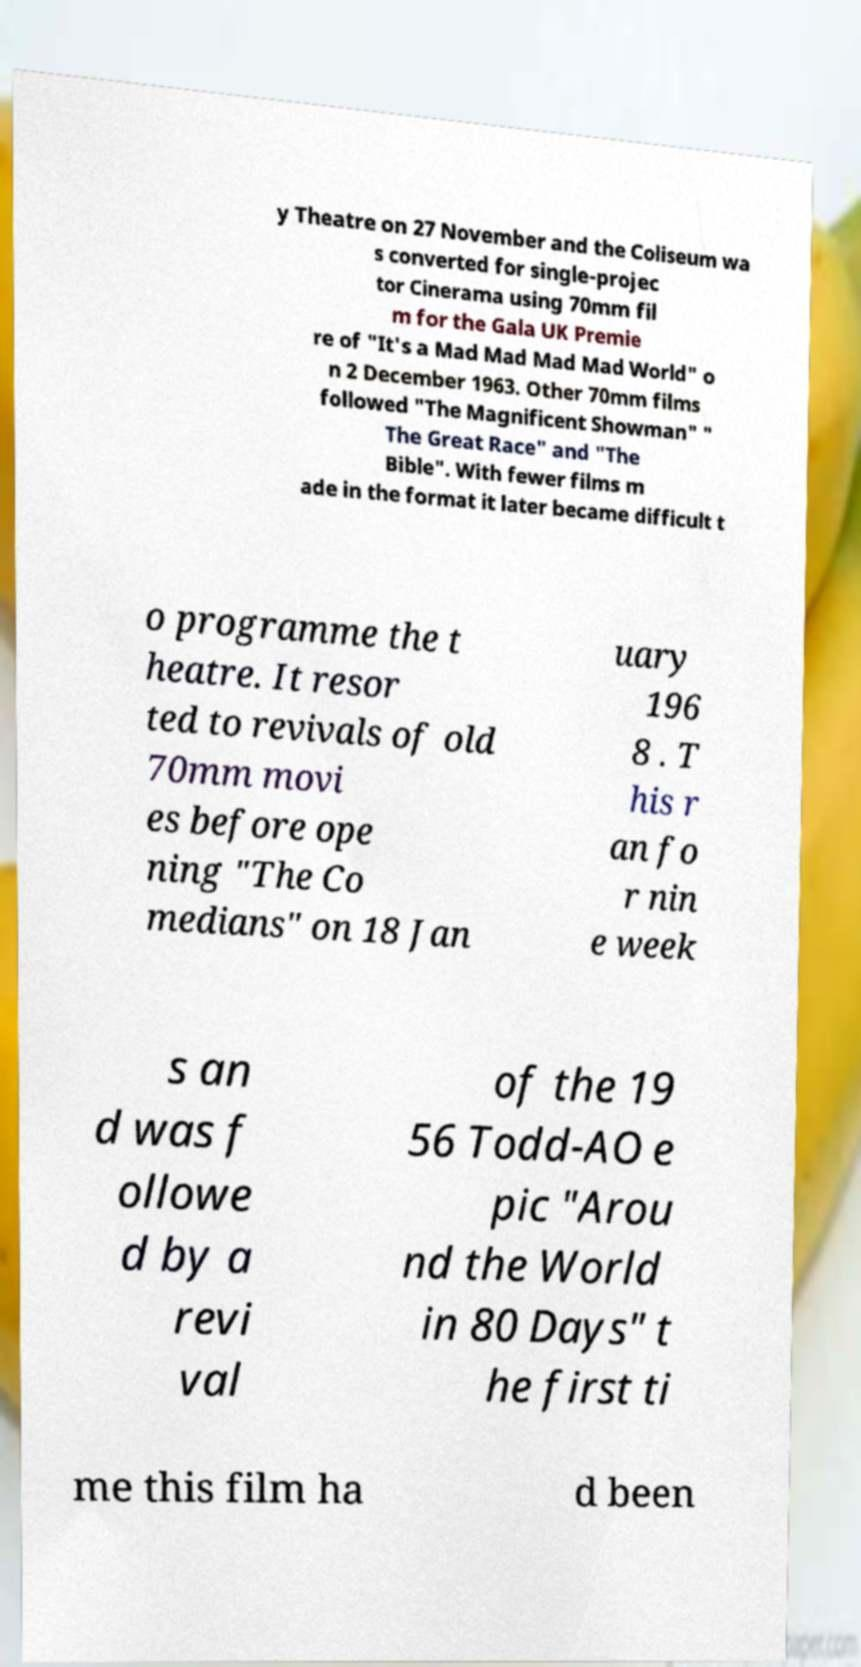Could you assist in decoding the text presented in this image and type it out clearly? y Theatre on 27 November and the Coliseum wa s converted for single-projec tor Cinerama using 70mm fil m for the Gala UK Premie re of "It's a Mad Mad Mad Mad World" o n 2 December 1963. Other 70mm films followed "The Magnificent Showman" " The Great Race" and "The Bible". With fewer films m ade in the format it later became difficult t o programme the t heatre. It resor ted to revivals of old 70mm movi es before ope ning "The Co medians" on 18 Jan uary 196 8 . T his r an fo r nin e week s an d was f ollowe d by a revi val of the 19 56 Todd-AO e pic "Arou nd the World in 80 Days" t he first ti me this film ha d been 